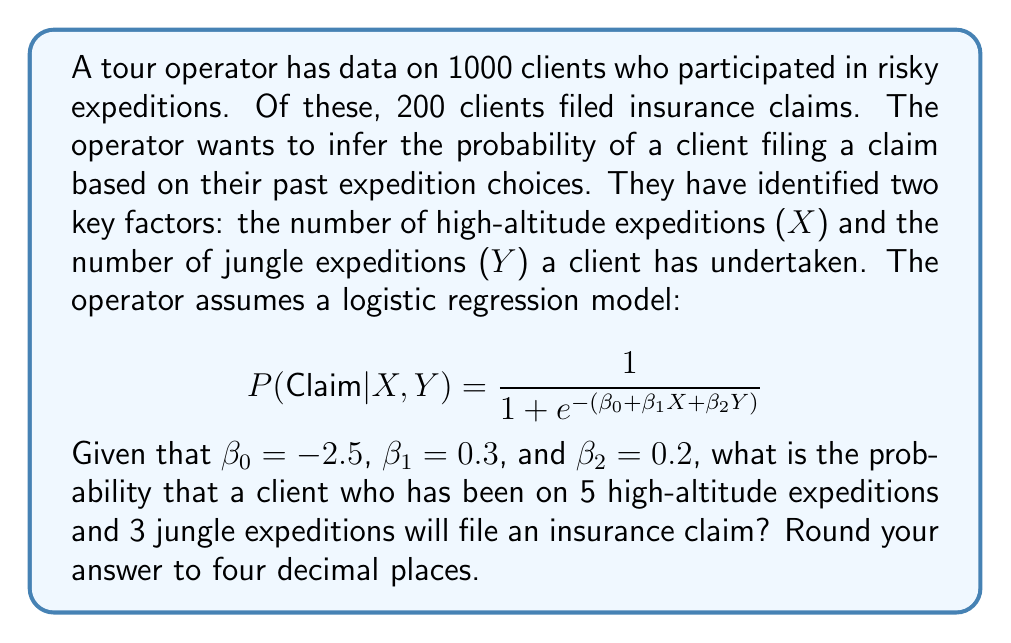Provide a solution to this math problem. To solve this problem, we need to follow these steps:

1. Identify the given information:
   $\beta_0 = -2.5$
   $\beta_1 = 0.3$
   $\beta_2 = 0.2$
   $X = 5$ (number of high-altitude expeditions)
   $Y = 3$ (number of jungle expeditions)

2. Substitute these values into the logistic regression equation:

   $$ P(Claim|X,Y) = \frac{1}{1 + e^{-(\beta_0 + \beta_1X + \beta_2Y)}} $$

3. Calculate the exponent:
   $-(\beta_0 + \beta_1X + \beta_2Y) = -(-2.5 + 0.3 * 5 + 0.2 * 3)$
   $= -(1.5 + 0.6)$
   $= -2.1$

4. Substitute this value into the equation:

   $$ P(Claim|X,Y) = \frac{1}{1 + e^{-(-2.1)}} = \frac{1}{1 + e^{2.1}} $$

5. Calculate $e^{2.1}$:
   $e^{2.1} \approx 8.1662$

6. Finish the calculation:

   $$ P(Claim|X,Y) = \frac{1}{1 + 8.1662} = \frac{1}{9.1662} \approx 0.1091 $$

7. Round to four decimal places: 0.1091

Therefore, the probability that this client will file an insurance claim is approximately 0.1091 or 10.91%.
Answer: 0.1091 